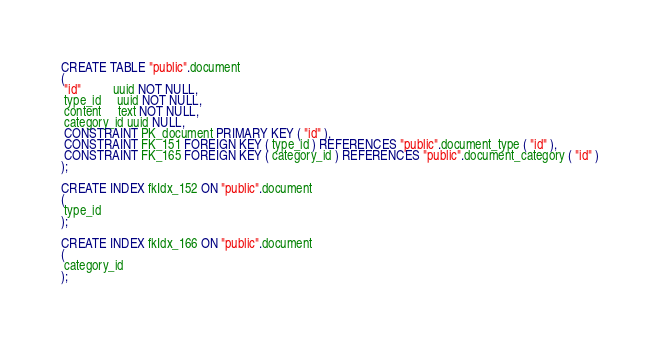<code> <loc_0><loc_0><loc_500><loc_500><_SQL_>CREATE TABLE "public".document
(
 "id"          uuid NOT NULL,
 type_id     uuid NOT NULL,
 content     text NOT NULL,
 category_id uuid NULL,
 CONSTRAINT PK_document PRIMARY KEY ( "id" ),
 CONSTRAINT FK_151 FOREIGN KEY ( type_id ) REFERENCES "public".document_type ( "id" ),
 CONSTRAINT FK_165 FOREIGN KEY ( category_id ) REFERENCES "public".document_category ( "id" )
);

CREATE INDEX fkIdx_152 ON "public".document
(
 type_id
);

CREATE INDEX fkIdx_166 ON "public".document
(
 category_id
);
</code> 